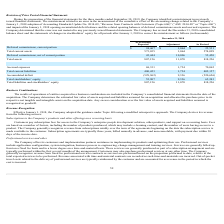According to Cornerstone Ondemand's financial document, Which date's opening accumulated deficit balance did the company's misstatement affect? According to the financial document, January 1, 2018. The relevant text states: "of the accounting change related to the Company’s January 1, 2018 adoption of Accounting Standards Update No. 2014-09, “Revenue from Contracts with Customers (Topic of the accounting change related to..." Also, What was the total current assets as previously reported? According to the financial document, 573,035 (in thousands). The relevant text states: "Total current assets 573,035 1,064 574,099..." Also, What were the total assets as revised? According to the financial document, 818,226 (in thousands). The relevant text states: "Total assets 807,156 11,070 818,226..." Also, can you calculate: What was the total adjustment of total current assets and total assets? Based on the calculation: 1,064+11,070, the result is 12134 (in thousands). This is based on the information: "Total assets 807,156 11,070 818,226 Deferred commissions, current portion $ 24,467 $ 1,064 $ 25,531..." The key data points involved are: 1,064, 11,070. Also, can you calculate: What was the sum of deferred commissions, current portion and total current assets as previously reported? Based on the calculation: $24,467+573,035, the result is 597502 (in thousands). This is based on the information: "Deferred commissions, current portion $ 24,467 $ 1,064 $ 25,531 Total current assets 573,035 1,064 574,099..." The key data points involved are: 24,467, 573,035. Also, can you calculate: What was accrued expenses as revised as a percentage of total liabilities and stockholders' equity? Based on the calculation: (70,065/818,226), the result is 8.56 (percentage). This is based on the information: "Total assets 807,156 11,070 818,226 Accrued expenses 68,331 1,734 70,065..." The key data points involved are: 70,065, 818,226. 